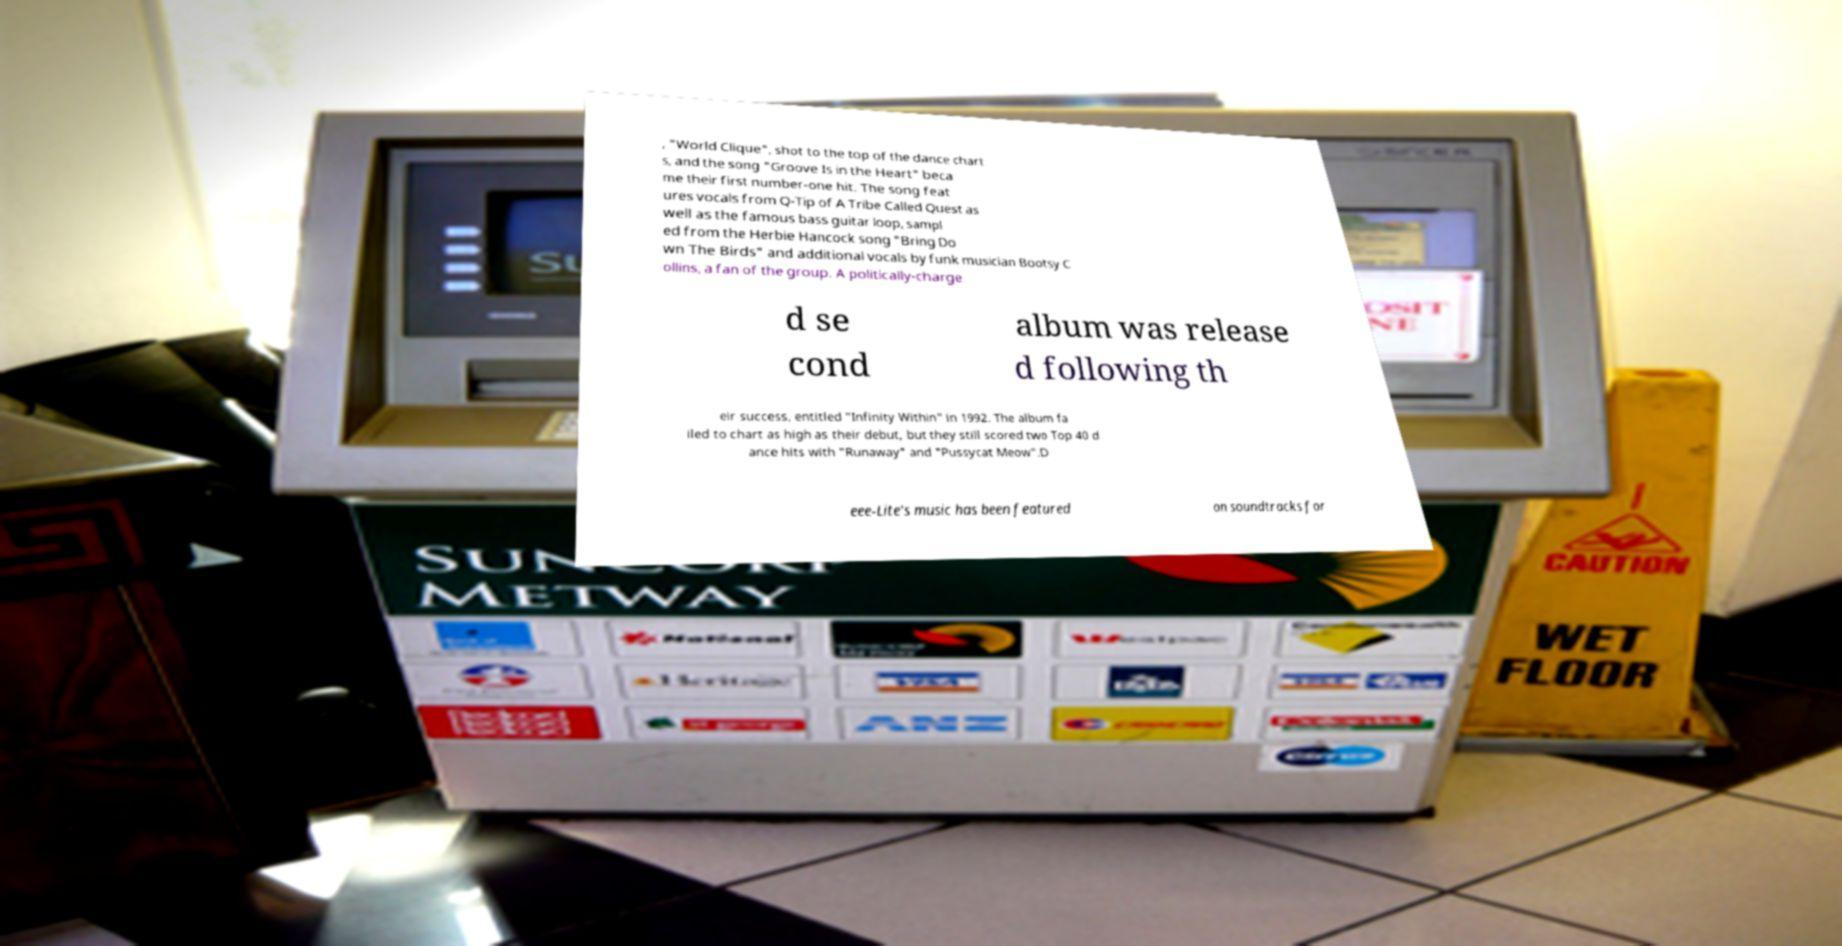I need the written content from this picture converted into text. Can you do that? , "World Clique", shot to the top of the dance chart s, and the song "Groove Is in the Heart" beca me their first number-one hit. The song feat ures vocals from Q-Tip of A Tribe Called Quest as well as the famous bass guitar loop, sampl ed from the Herbie Hancock song "Bring Do wn The Birds" and additional vocals by funk musician Bootsy C ollins, a fan of the group. A politically-charge d se cond album was release d following th eir success, entitled "Infinity Within" in 1992. The album fa iled to chart as high as their debut, but they still scored two Top 40 d ance hits with "Runaway" and "Pussycat Meow".D eee-Lite's music has been featured on soundtracks for 